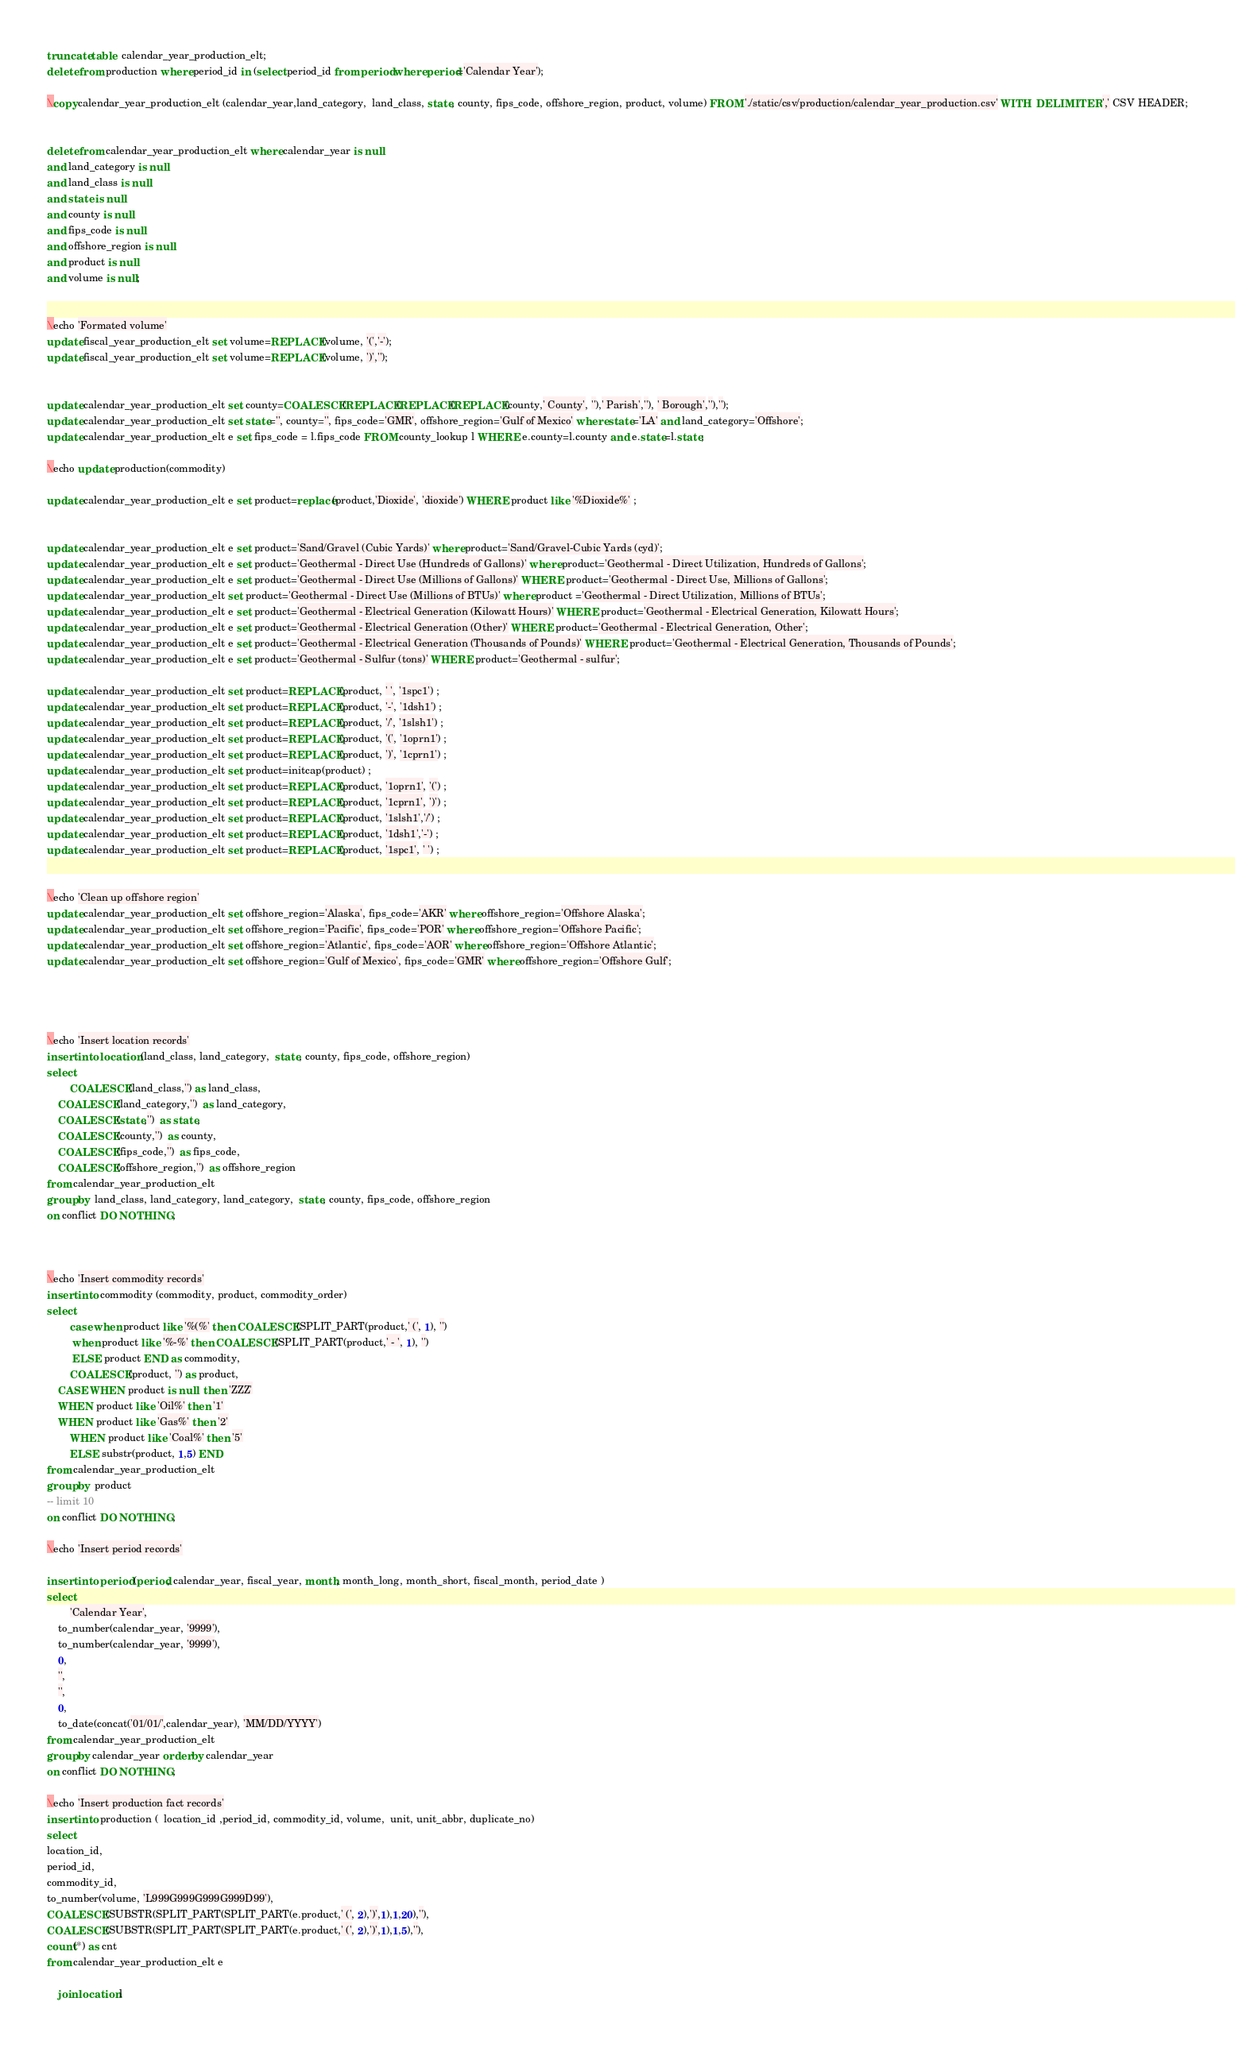Convert code to text. <code><loc_0><loc_0><loc_500><loc_500><_SQL_>truncate table  calendar_year_production_elt;
delete from production where period_id in (select period_id from period where period='Calendar Year');

\copy calendar_year_production_elt (calendar_year,land_category,  land_class, state, county, fips_code, offshore_region, product, volume) FROM './static/csv/production/calendar_year_production.csv' WITH  DELIMITER ',' CSV HEADER;


delete from calendar_year_production_elt where calendar_year is null
and land_category is null 
and land_class is null
and state is null
and county is null
and fips_code is null
and offshore_region is null
and product is null
and volume is null;


\echo 'Formated volume'
update fiscal_year_production_elt set volume=REPLACE(volume, '(','-');
update fiscal_year_production_elt set volume=REPLACE(volume, ')',''); 


update calendar_year_production_elt set county=COALESCE(REPLACE(REPLACE(REPLACE(county,' County', ''),' Parish',''), ' Borough',''),'');
update calendar_year_production_elt set state='', county='', fips_code='GMR', offshore_region='Gulf of Mexico' where state='LA' and land_category='Offshore'; 
update calendar_year_production_elt e set fips_code = l.fips_code FROM county_lookup l WHERE e.county=l.county and e.state=l.state;

\echo update production(commodity)

update calendar_year_production_elt e set product=replace(product,'Dioxide', 'dioxide') WHERE product like '%Dioxide%' ;


update calendar_year_production_elt e set product='Sand/Gravel (Cubic Yards)' where product='Sand/Gravel-Cubic Yards (cyd)';
update calendar_year_production_elt e set product='Geothermal - Direct Use (Hundreds of Gallons)' where product='Geothermal - Direct Utilization, Hundreds of Gallons';
update calendar_year_production_elt e set product='Geothermal - Direct Use (Millions of Gallons)' WHERE product='Geothermal - Direct Use, Millions of Gallons';
update calendar_year_production_elt set product='Geothermal - Direct Use (Millions of BTUs)' where product ='Geothermal - Direct Utilization, Millions of BTUs';
update calendar_year_production_elt e set product='Geothermal - Electrical Generation (Kilowatt Hours)' WHERE product='Geothermal - Electrical Generation, Kilowatt Hours';
update calendar_year_production_elt e set product='Geothermal - Electrical Generation (Other)' WHERE product='Geothermal - Electrical Generation, Other';
update calendar_year_production_elt e set product='Geothermal - Electrical Generation (Thousands of Pounds)' WHERE product='Geothermal - Electrical Generation, Thousands of Pounds';
update calendar_year_production_elt e set product='Geothermal - Sulfur (tons)' WHERE product='Geothermal - sulfur';

update calendar_year_production_elt set product=REPLACE(product, ' ', '1spc1') ;
update calendar_year_production_elt set product=REPLACE(product, '-', '1dsh1') ;
update calendar_year_production_elt set product=REPLACE(product, '/', '1slsh1') ;
update calendar_year_production_elt set product=REPLACE(product, '(', '1oprn1') ;
update calendar_year_production_elt set product=REPLACE(product, ')', '1cprn1') ;
update calendar_year_production_elt set product=initcap(product) ;
update calendar_year_production_elt set product=REPLACE(product, '1oprn1', '(') ;
update calendar_year_production_elt set product=REPLACE(product, '1cprn1', ')') ;
update calendar_year_production_elt set product=REPLACE(product, '1slsh1','/') ;
update calendar_year_production_elt set product=REPLACE(product, '1dsh1','-') ;
update calendar_year_production_elt set product=REPLACE(product, '1spc1', ' ') ;


\echo 'Clean up offshore region'
update calendar_year_production_elt set offshore_region='Alaska', fips_code='AKR' where offshore_region='Offshore Alaska';
update calendar_year_production_elt set offshore_region='Pacific', fips_code='POR' where offshore_region='Offshore Pacific';
update calendar_year_production_elt set offshore_region='Atlantic', fips_code='AOR' where offshore_region='Offshore Atlantic';
update calendar_year_production_elt set offshore_region='Gulf of Mexico', fips_code='GMR' where offshore_region='Offshore Gulf';




\echo 'Insert location records'
insert into location (land_class, land_category,  state, county, fips_code, offshore_region)
select
       	COALESCE(land_class,'') as land_class,
	COALESCE(land_category,'')  as land_category,
	COALESCE(state,'')  as state,
	COALESCE(county,'')  as county,
	COALESCE(fips_code,'')  as fips_code,
	COALESCE(offshore_region,'')  as offshore_region
from calendar_year_production_elt
group by  land_class, land_category, land_category,  state, county, fips_code, offshore_region
on conflict DO NOTHING;



\echo 'Insert commodity records'
insert into commodity (commodity, product, commodity_order)
select
        case when product like '%(%' then COALESCE(SPLIT_PART(product,' (', 1), '')
	     when product like '%-%' then COALESCE(SPLIT_PART(product,' - ', 1), '')
	     ELSE product END as commodity,
        COALESCE(product, '') as product,
	CASE WHEN product is null  then 'ZZZ' 
	WHEN product like 'Oil%' then '1' 
	WHEN product like 'Gas%' then '2'
        WHEN product like 'Coal%' then '5' 
        ELSE substr(product, 1,5) END
from calendar_year_production_elt
group by  product
-- limit 10
on conflict DO NOTHING;

\echo 'Insert period records'

insert into period (period, calendar_year, fiscal_year, month, month_long, month_short, fiscal_month, period_date )
select
        'Calendar Year',
	to_number(calendar_year, '9999'),
	to_number(calendar_year, '9999'),
	0,
	'',
	'',
	0,
	to_date(concat('01/01/',calendar_year), 'MM/DD/YYYY')
from calendar_year_production_elt
group by calendar_year order by calendar_year
on conflict DO NOTHING;

\echo 'Insert production fact records'
insert into production (  location_id ,period_id, commodity_id, volume,  unit, unit_abbr, duplicate_no)
select
location_id,
period_id,
commodity_id,
to_number(volume, 'L999G999G999G999D99'),
COALESCE(SUBSTR(SPLIT_PART(SPLIT_PART(e.product,' (', 2),')',1),1,20),''),
COALESCE(SUBSTR(SPLIT_PART(SPLIT_PART(e.product,' (', 2),')',1),1,5),''),
count(*) as cnt
from calendar_year_production_elt e

    join location l</code> 